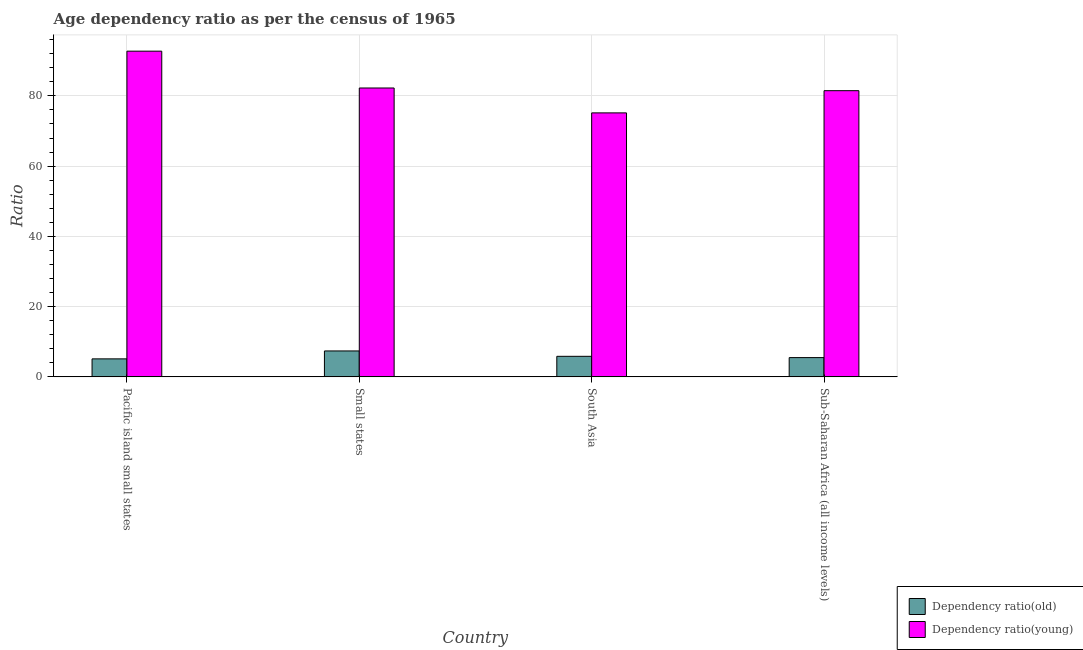How many different coloured bars are there?
Your answer should be compact. 2. Are the number of bars on each tick of the X-axis equal?
Offer a terse response. Yes. How many bars are there on the 4th tick from the right?
Ensure brevity in your answer.  2. What is the label of the 4th group of bars from the left?
Provide a succinct answer. Sub-Saharan Africa (all income levels). What is the age dependency ratio(old) in Sub-Saharan Africa (all income levels)?
Your answer should be very brief. 5.49. Across all countries, what is the maximum age dependency ratio(old)?
Give a very brief answer. 7.38. Across all countries, what is the minimum age dependency ratio(young)?
Provide a succinct answer. 75.16. In which country was the age dependency ratio(old) maximum?
Your answer should be very brief. Small states. In which country was the age dependency ratio(young) minimum?
Ensure brevity in your answer.  South Asia. What is the total age dependency ratio(young) in the graph?
Provide a short and direct response. 331.62. What is the difference between the age dependency ratio(old) in Small states and that in South Asia?
Ensure brevity in your answer.  1.53. What is the difference between the age dependency ratio(old) in Sub-Saharan Africa (all income levels) and the age dependency ratio(young) in Pacific island small states?
Offer a terse response. -87.25. What is the average age dependency ratio(young) per country?
Give a very brief answer. 82.91. What is the difference between the age dependency ratio(old) and age dependency ratio(young) in South Asia?
Make the answer very short. -69.31. In how many countries, is the age dependency ratio(old) greater than 72 ?
Offer a terse response. 0. What is the ratio of the age dependency ratio(young) in South Asia to that in Sub-Saharan Africa (all income levels)?
Ensure brevity in your answer.  0.92. Is the difference between the age dependency ratio(young) in South Asia and Sub-Saharan Africa (all income levels) greater than the difference between the age dependency ratio(old) in South Asia and Sub-Saharan Africa (all income levels)?
Give a very brief answer. No. What is the difference between the highest and the second highest age dependency ratio(old)?
Make the answer very short. 1.53. What is the difference between the highest and the lowest age dependency ratio(old)?
Ensure brevity in your answer.  2.26. What does the 2nd bar from the left in South Asia represents?
Make the answer very short. Dependency ratio(young). What does the 1st bar from the right in South Asia represents?
Your answer should be compact. Dependency ratio(young). How many countries are there in the graph?
Ensure brevity in your answer.  4. What is the difference between two consecutive major ticks on the Y-axis?
Your answer should be compact. 20. Does the graph contain any zero values?
Ensure brevity in your answer.  No. Does the graph contain grids?
Give a very brief answer. Yes. How are the legend labels stacked?
Give a very brief answer. Vertical. What is the title of the graph?
Keep it short and to the point. Age dependency ratio as per the census of 1965. What is the label or title of the Y-axis?
Ensure brevity in your answer.  Ratio. What is the Ratio in Dependency ratio(old) in Pacific island small states?
Provide a succinct answer. 5.13. What is the Ratio in Dependency ratio(young) in Pacific island small states?
Give a very brief answer. 92.73. What is the Ratio in Dependency ratio(old) in Small states?
Offer a terse response. 7.38. What is the Ratio of Dependency ratio(young) in Small states?
Keep it short and to the point. 82.25. What is the Ratio in Dependency ratio(old) in South Asia?
Your answer should be compact. 5.85. What is the Ratio in Dependency ratio(young) in South Asia?
Offer a very short reply. 75.16. What is the Ratio in Dependency ratio(old) in Sub-Saharan Africa (all income levels)?
Make the answer very short. 5.49. What is the Ratio in Dependency ratio(young) in Sub-Saharan Africa (all income levels)?
Give a very brief answer. 81.48. Across all countries, what is the maximum Ratio in Dependency ratio(old)?
Offer a very short reply. 7.38. Across all countries, what is the maximum Ratio in Dependency ratio(young)?
Keep it short and to the point. 92.73. Across all countries, what is the minimum Ratio in Dependency ratio(old)?
Keep it short and to the point. 5.13. Across all countries, what is the minimum Ratio of Dependency ratio(young)?
Keep it short and to the point. 75.16. What is the total Ratio of Dependency ratio(old) in the graph?
Ensure brevity in your answer.  23.85. What is the total Ratio of Dependency ratio(young) in the graph?
Ensure brevity in your answer.  331.62. What is the difference between the Ratio in Dependency ratio(old) in Pacific island small states and that in Small states?
Provide a succinct answer. -2.26. What is the difference between the Ratio in Dependency ratio(young) in Pacific island small states and that in Small states?
Offer a very short reply. 10.49. What is the difference between the Ratio of Dependency ratio(old) in Pacific island small states and that in South Asia?
Your response must be concise. -0.73. What is the difference between the Ratio in Dependency ratio(young) in Pacific island small states and that in South Asia?
Offer a terse response. 17.57. What is the difference between the Ratio in Dependency ratio(old) in Pacific island small states and that in Sub-Saharan Africa (all income levels)?
Make the answer very short. -0.36. What is the difference between the Ratio in Dependency ratio(young) in Pacific island small states and that in Sub-Saharan Africa (all income levels)?
Provide a short and direct response. 11.25. What is the difference between the Ratio in Dependency ratio(old) in Small states and that in South Asia?
Ensure brevity in your answer.  1.53. What is the difference between the Ratio of Dependency ratio(young) in Small states and that in South Asia?
Give a very brief answer. 7.09. What is the difference between the Ratio in Dependency ratio(old) in Small states and that in Sub-Saharan Africa (all income levels)?
Ensure brevity in your answer.  1.9. What is the difference between the Ratio of Dependency ratio(young) in Small states and that in Sub-Saharan Africa (all income levels)?
Offer a very short reply. 0.77. What is the difference between the Ratio in Dependency ratio(old) in South Asia and that in Sub-Saharan Africa (all income levels)?
Ensure brevity in your answer.  0.37. What is the difference between the Ratio in Dependency ratio(young) in South Asia and that in Sub-Saharan Africa (all income levels)?
Offer a terse response. -6.32. What is the difference between the Ratio of Dependency ratio(old) in Pacific island small states and the Ratio of Dependency ratio(young) in Small states?
Provide a short and direct response. -77.12. What is the difference between the Ratio in Dependency ratio(old) in Pacific island small states and the Ratio in Dependency ratio(young) in South Asia?
Keep it short and to the point. -70.03. What is the difference between the Ratio in Dependency ratio(old) in Pacific island small states and the Ratio in Dependency ratio(young) in Sub-Saharan Africa (all income levels)?
Your answer should be very brief. -76.36. What is the difference between the Ratio of Dependency ratio(old) in Small states and the Ratio of Dependency ratio(young) in South Asia?
Provide a short and direct response. -67.78. What is the difference between the Ratio in Dependency ratio(old) in Small states and the Ratio in Dependency ratio(young) in Sub-Saharan Africa (all income levels)?
Your answer should be very brief. -74.1. What is the difference between the Ratio in Dependency ratio(old) in South Asia and the Ratio in Dependency ratio(young) in Sub-Saharan Africa (all income levels)?
Give a very brief answer. -75.63. What is the average Ratio of Dependency ratio(old) per country?
Provide a short and direct response. 5.96. What is the average Ratio in Dependency ratio(young) per country?
Your answer should be compact. 82.91. What is the difference between the Ratio of Dependency ratio(old) and Ratio of Dependency ratio(young) in Pacific island small states?
Give a very brief answer. -87.61. What is the difference between the Ratio of Dependency ratio(old) and Ratio of Dependency ratio(young) in Small states?
Offer a terse response. -74.86. What is the difference between the Ratio of Dependency ratio(old) and Ratio of Dependency ratio(young) in South Asia?
Offer a terse response. -69.31. What is the difference between the Ratio of Dependency ratio(old) and Ratio of Dependency ratio(young) in Sub-Saharan Africa (all income levels)?
Provide a succinct answer. -76. What is the ratio of the Ratio in Dependency ratio(old) in Pacific island small states to that in Small states?
Keep it short and to the point. 0.69. What is the ratio of the Ratio in Dependency ratio(young) in Pacific island small states to that in Small states?
Make the answer very short. 1.13. What is the ratio of the Ratio of Dependency ratio(old) in Pacific island small states to that in South Asia?
Provide a short and direct response. 0.88. What is the ratio of the Ratio of Dependency ratio(young) in Pacific island small states to that in South Asia?
Offer a terse response. 1.23. What is the ratio of the Ratio in Dependency ratio(old) in Pacific island small states to that in Sub-Saharan Africa (all income levels)?
Offer a very short reply. 0.93. What is the ratio of the Ratio of Dependency ratio(young) in Pacific island small states to that in Sub-Saharan Africa (all income levels)?
Offer a terse response. 1.14. What is the ratio of the Ratio in Dependency ratio(old) in Small states to that in South Asia?
Your answer should be compact. 1.26. What is the ratio of the Ratio of Dependency ratio(young) in Small states to that in South Asia?
Offer a very short reply. 1.09. What is the ratio of the Ratio of Dependency ratio(old) in Small states to that in Sub-Saharan Africa (all income levels)?
Ensure brevity in your answer.  1.35. What is the ratio of the Ratio of Dependency ratio(young) in Small states to that in Sub-Saharan Africa (all income levels)?
Ensure brevity in your answer.  1.01. What is the ratio of the Ratio in Dependency ratio(old) in South Asia to that in Sub-Saharan Africa (all income levels)?
Ensure brevity in your answer.  1.07. What is the ratio of the Ratio in Dependency ratio(young) in South Asia to that in Sub-Saharan Africa (all income levels)?
Keep it short and to the point. 0.92. What is the difference between the highest and the second highest Ratio of Dependency ratio(old)?
Offer a terse response. 1.53. What is the difference between the highest and the second highest Ratio of Dependency ratio(young)?
Give a very brief answer. 10.49. What is the difference between the highest and the lowest Ratio of Dependency ratio(old)?
Make the answer very short. 2.26. What is the difference between the highest and the lowest Ratio in Dependency ratio(young)?
Provide a short and direct response. 17.57. 